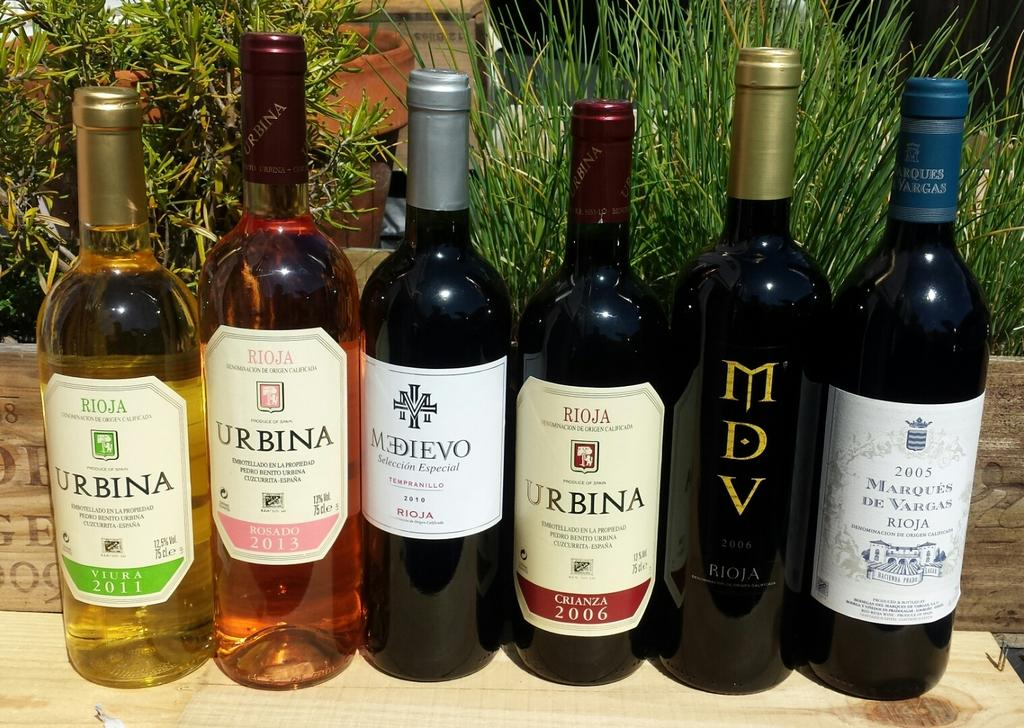<image>
Summarize the visual content of the image. A bottle of MDV Rioja is in a row of bottles of wine. 